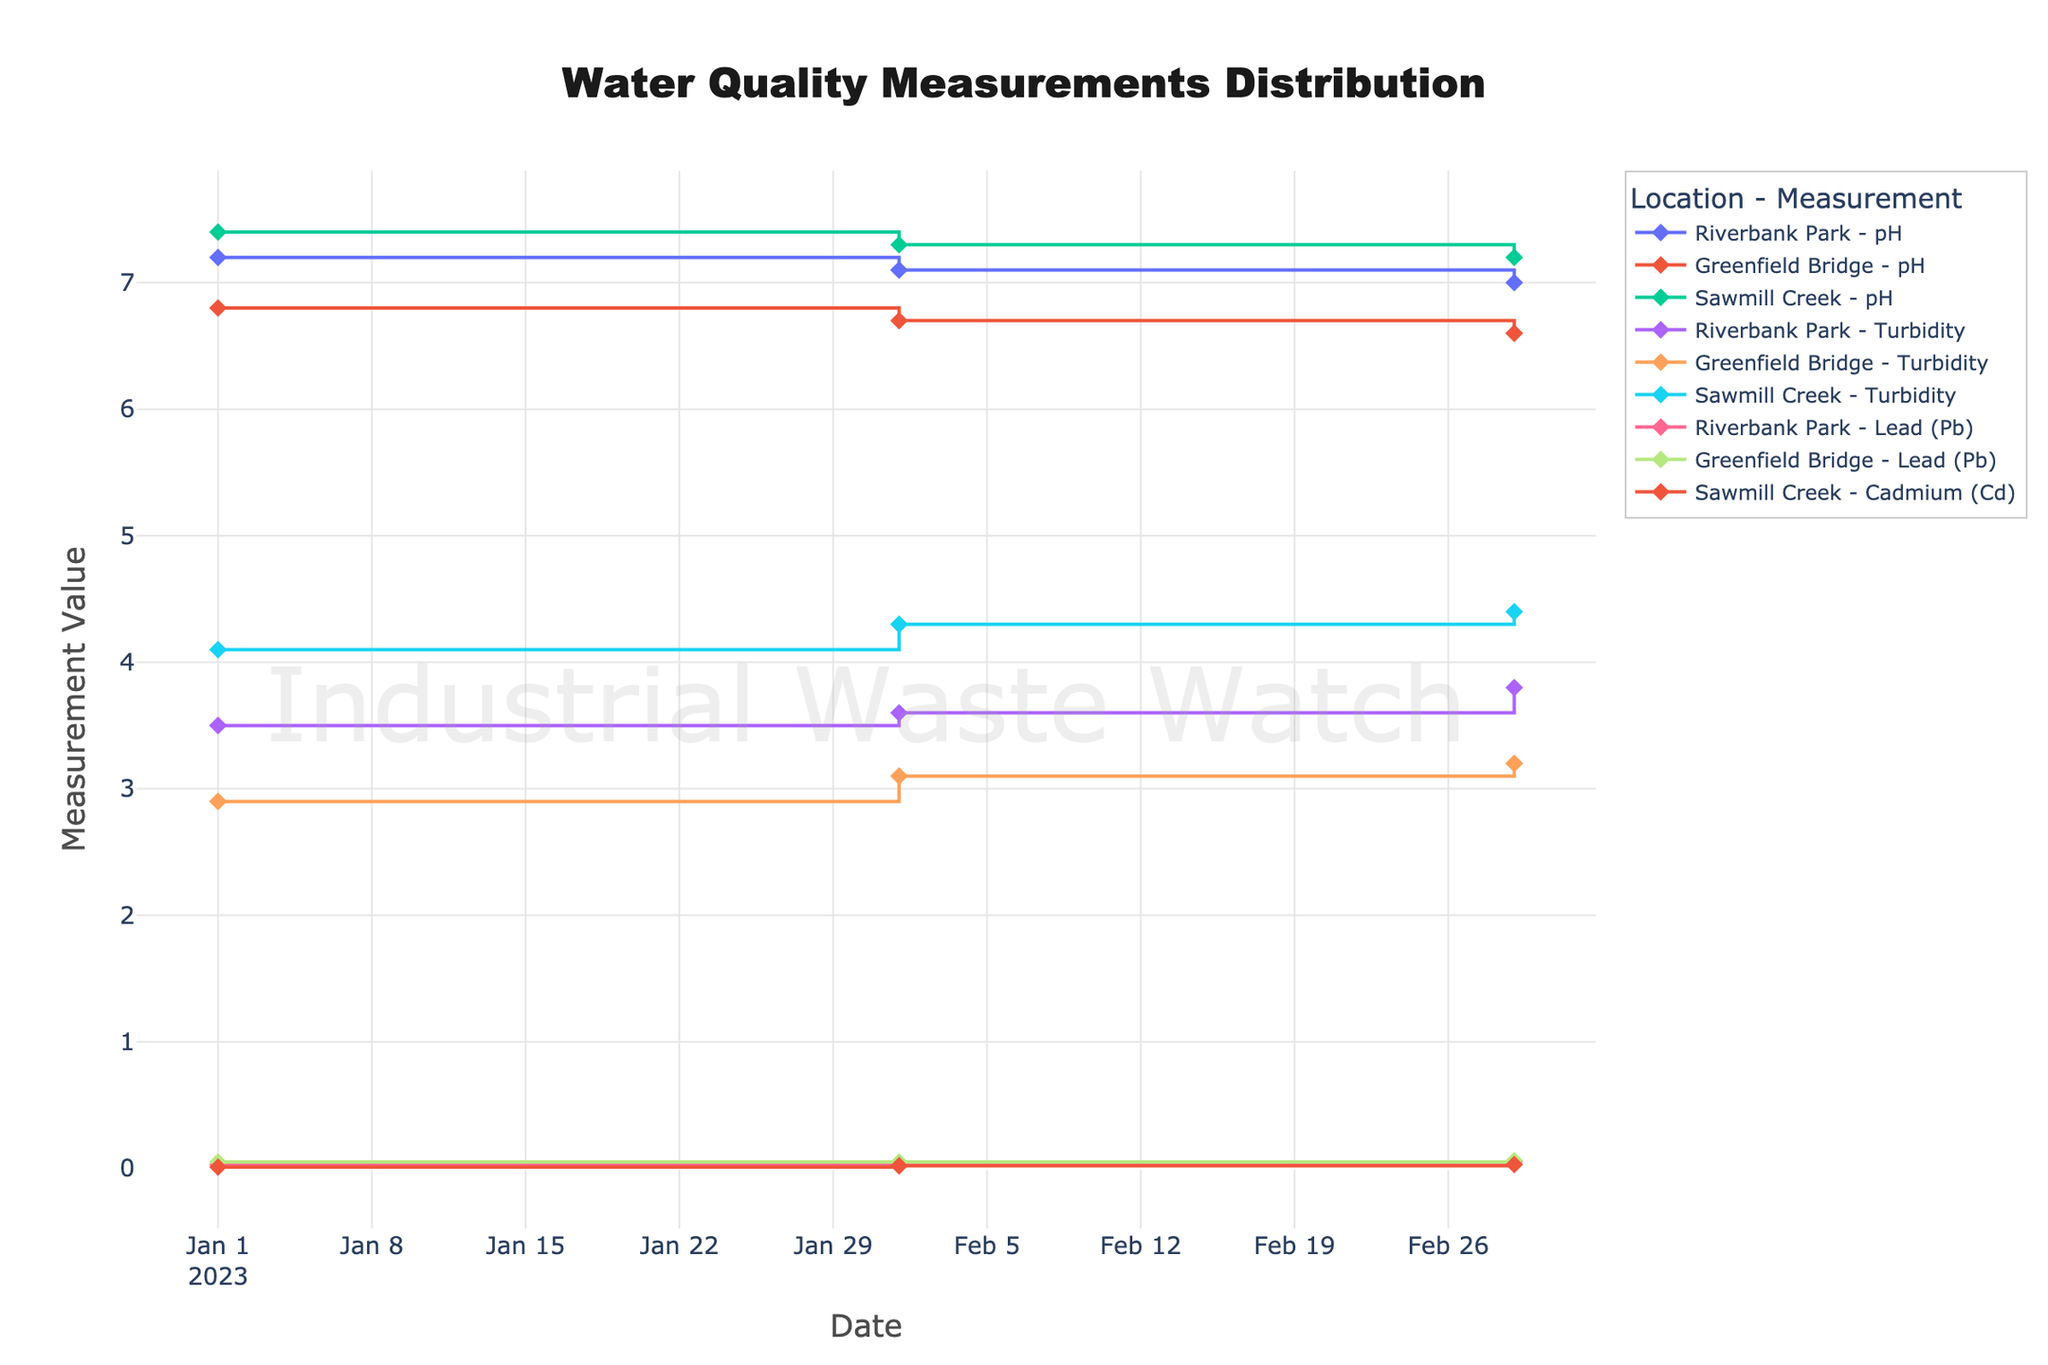Which location has the highest pH on March 1, 2023? To find the highest pH at each location for March 1, check the pH values on the x-axis for that date: Riverbank Park - 7.0, Greenfield Bridge - 6.6, and Sawmill Creek - 7.2. Sawmill Creek has the highest pH.
Answer: Sawmill Creek What is the difference in turbidity between Riverbank Park and Sawmill Creek on February 1, 2023? Locate the turbidity readings for Riverbank Park (3.6) and Sawmill Creek (4.3) on February 1. Subtract Riverbank Park's value from Sawmill Creek's value: 4.3 - 3.6 = 0.7.
Answer: 0.7 Which measurement type shows the most consistent values over the three months for Greenfield Bridge? Compare the variations in values for pH (6.8, 6.7, 6.6), Turbidity (2.9, 3.1, 3.2), and Lead (Pb) (0.05, 0.05, 0.06). Turbidity shows the least variation, indicating consistency.
Answer: Turbidity What is the average pH measurement for Riverbank Park over the given months? Calculate the average pH values at Riverbank Park across three dates: (7.2 + 7.1 + 7.0) / 3 = 7.1.
Answer: 7.1 Is there any trend in Lead (Pb) values at Riverbank Park over the three months? Observe the Lead (Pb) values for Riverbank Park: 0.03 in January, 0.04 in February, and 0.05 in March. There is a consistent increase each month.
Answer: Increasing trend Which location has the highest turbidity value on January 1, 2023? Compare the turbidity values on January 1 for Riverbank Park (3.5), Greenfield Bridge (2.9), and Sawmill Creek (4.1). Sawmill Creek shows the highest turbidity.
Answer: Sawmill Creek How does the pH trend at Greenfield Bridge compare to Sawmill Creek over the three months? Observe the pH values at Greenfield Bridge (6.8, 6.7, 6.6) and Sawmill Creek (7.4, 7.3, 7.2). Both show a decreasing trend, but Greenfield Bridge's values decrease more rapidly.
Answer: Both decrease, but Greenfield Bridge decreases more rapidly 